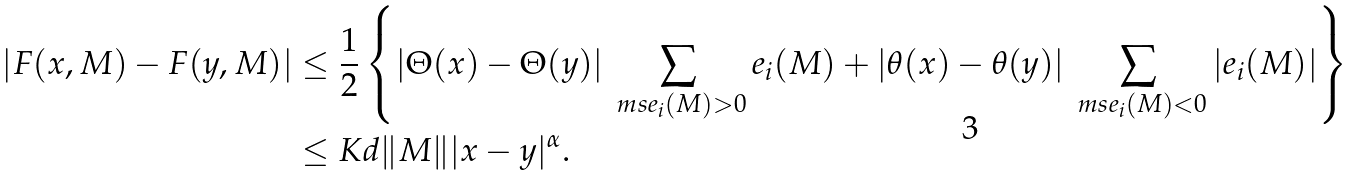Convert formula to latex. <formula><loc_0><loc_0><loc_500><loc_500>| F ( x , M ) - F ( y , M ) | & \leq \frac { 1 } { 2 } \left \{ | \Theta ( x ) - \Theta ( y ) | \sum _ { \ m s e _ { i } ( M ) > 0 } e _ { i } ( M ) + | \theta ( x ) - \theta ( y ) | \sum _ { \ m s e _ { i } ( M ) < 0 } | e _ { i } ( M ) | \right \} \\ & \leq K d \| M \| | x - y | ^ { \alpha } .</formula> 